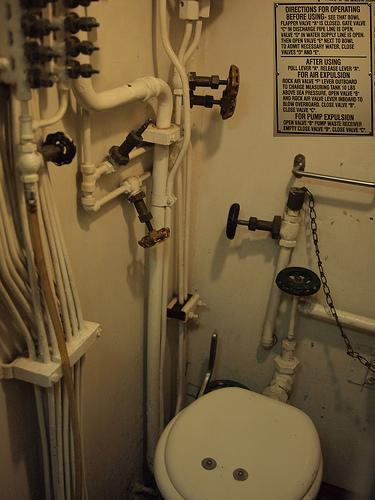Identify any hanging object in the scene and its color. There is a sign hanging over a space in the image, which is white with black letters. Using technical language, describe the plumbing system displayed in the image. The image showcases a white toilet with the lid down, connected to an extensive network of white pipes on a wall, including a black tap as part of the plumbing system. Point out the visibility and condition of the wall in the image. In the image, a white wall is visible and appears slightly dirty. Mention any object indicating an action in the photograph, along with its color. There is a chain for flushing the toilet, which is black in color. Briefly describe the location and appearance of the main object in the image. A white toilet with a closed lid is situated in a bathroom with white walls. List any visible bathroom accessories and their colors. Some visible bathroom accessories are a white toilet lid, a black tap, and white pipes on the wall. Describe an element in the image related to hygiene. A closed white toilet lid indicates a clean and well-maintained bathroom environment. Mention the primary object in the picture and its color. The primary object in the picture is a white toilet with the lid down. Enumerate three key items in the image and their colors. A white toilet with the lid down, white pipes on the wall, and a black tap. Express the general theme of the image using figurative language. A pristine porcelain throne rests amidst an orchestra of pipes and wires, patiently awaiting its call to duty. 